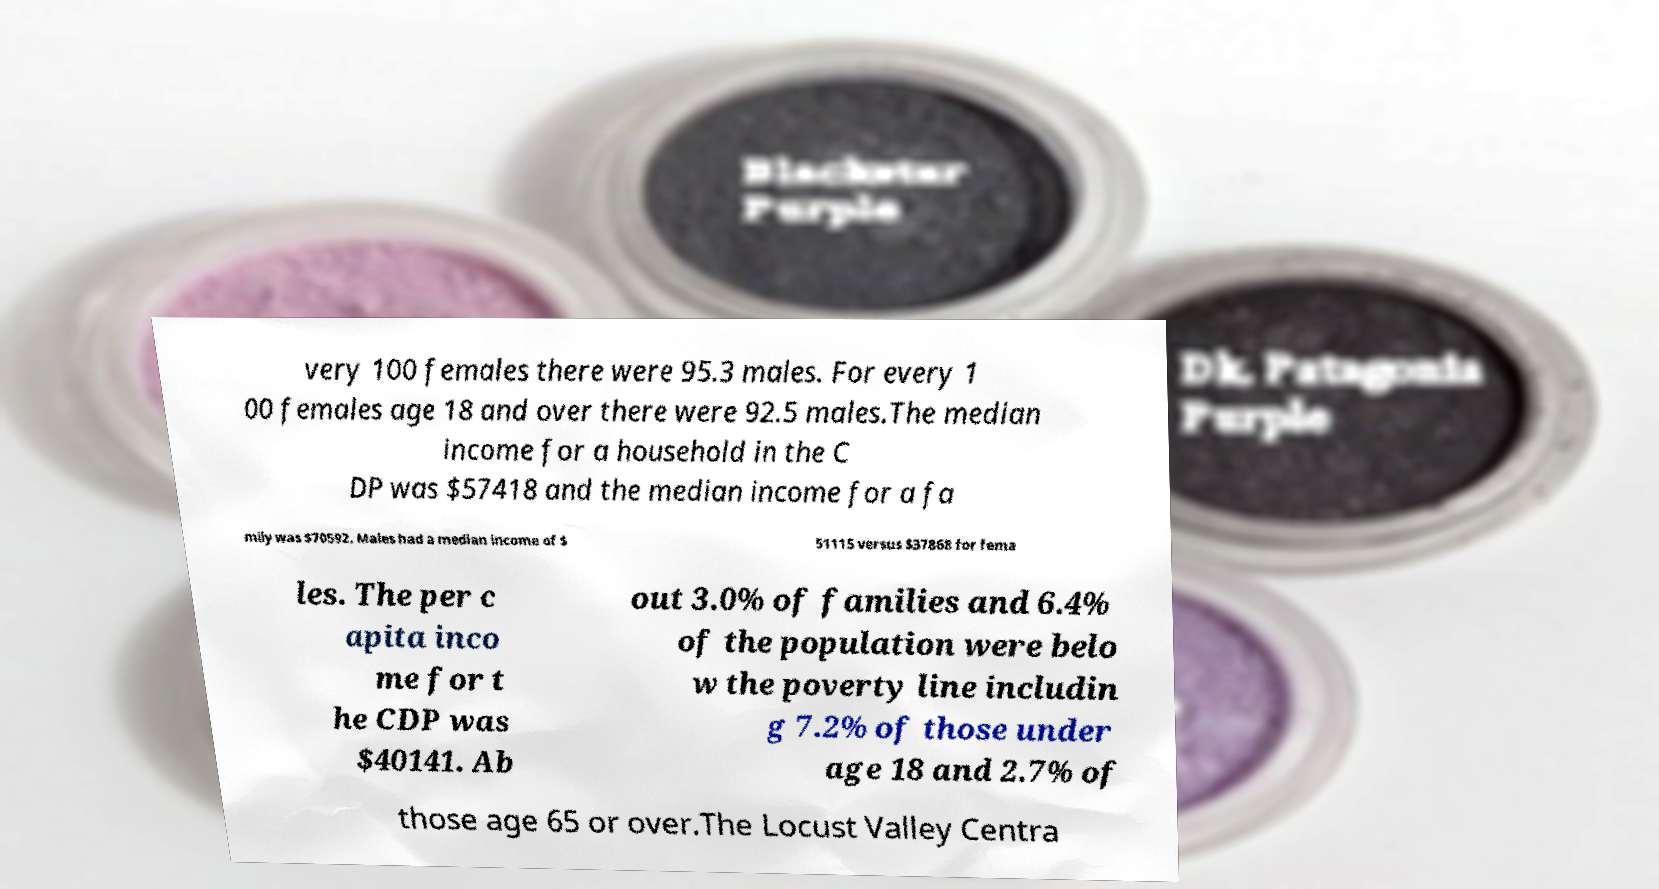I need the written content from this picture converted into text. Can you do that? very 100 females there were 95.3 males. For every 1 00 females age 18 and over there were 92.5 males.The median income for a household in the C DP was $57418 and the median income for a fa mily was $70592. Males had a median income of $ 51115 versus $37868 for fema les. The per c apita inco me for t he CDP was $40141. Ab out 3.0% of families and 6.4% of the population were belo w the poverty line includin g 7.2% of those under age 18 and 2.7% of those age 65 or over.The Locust Valley Centra 